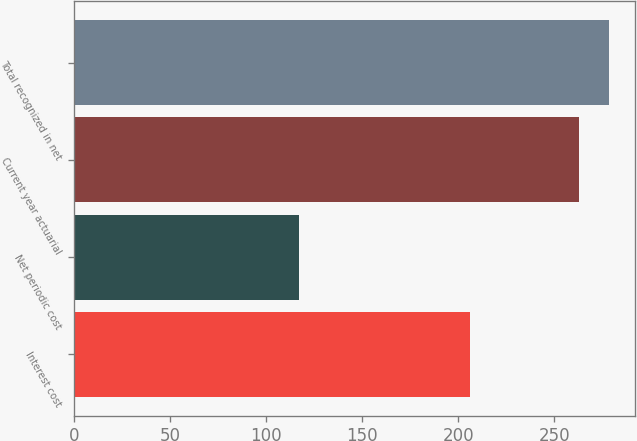Convert chart. <chart><loc_0><loc_0><loc_500><loc_500><bar_chart><fcel>Interest cost<fcel>Net periodic cost<fcel>Current year actuarial<fcel>Total recognized in net<nl><fcel>206<fcel>117<fcel>263<fcel>278.3<nl></chart> 